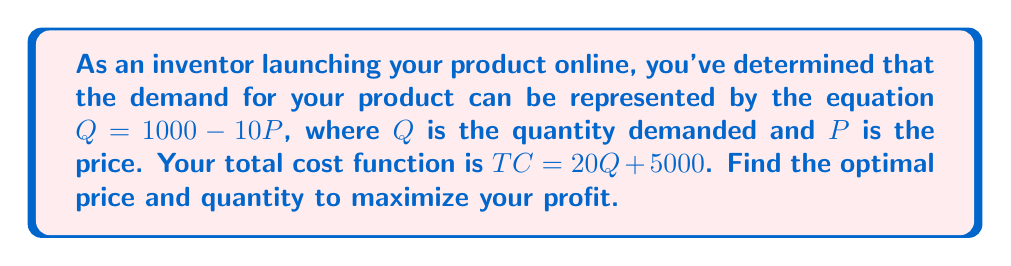Can you solve this math problem? To solve this problem, we'll follow these steps:

1) First, let's define the profit function. Profit = Revenue - Total Cost
   $\pi = PQ - TC$

2) Substitute the given equations:
   $\pi = P(1000 - 10P) - (20(1000 - 10P) + 5000)$

3) Expand the equation:
   $\pi = 1000P - 10P^2 - 20000 + 200P - 5000$
   $\pi = -10P^2 + 1200P - 25000$

4) To find the maximum profit, we need to find where the derivative of the profit function equals zero:
   $\frac{d\pi}{dP} = -20P + 1200 = 0$

5) Solve for P:
   $-20P = -1200$
   $P = 60$

6) To confirm this is a maximum, check the second derivative:
   $\frac{d^2\pi}{dP^2} = -20$, which is negative, confirming a maximum.

7) Now that we know the optimal price, we can find the optimal quantity:
   $Q = 1000 - 10P = 1000 - 10(60) = 400$

Therefore, the optimal price is $60 and the optimal quantity is 400 units.
Answer: $P = 60, Q = 400$ 